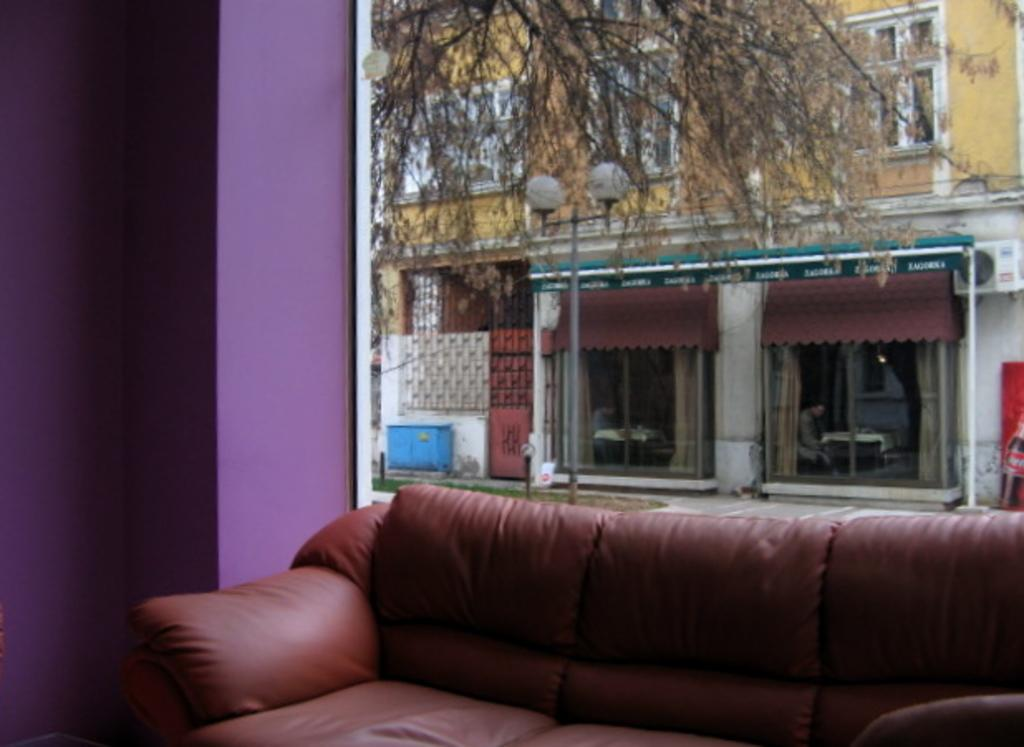What type of furniture is in the image? There is a couch in the image. What color is the wall on the left side of the image? The wall on the left side of the image is purple. What can be seen in the background of the image? There are trees and another building in the background of the image. What type of oatmeal is being used as a decoration on the couch in the image? There is no oatmeal present in the image, and it is not being used as a decoration on the couch. 